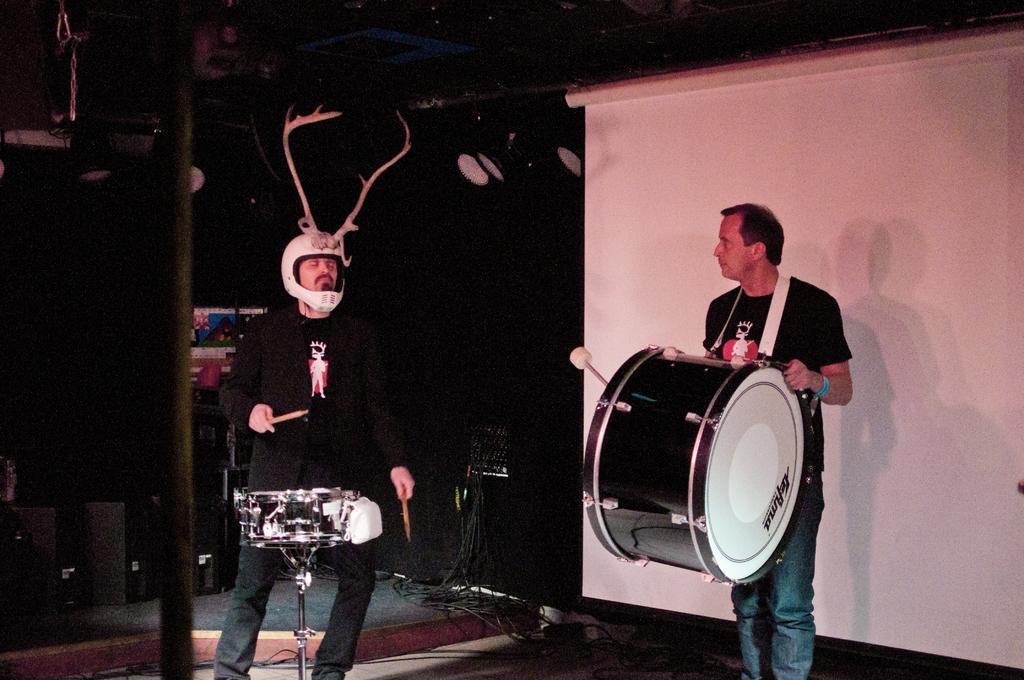Describe this image in one or two sentences. Two men are playing drums 